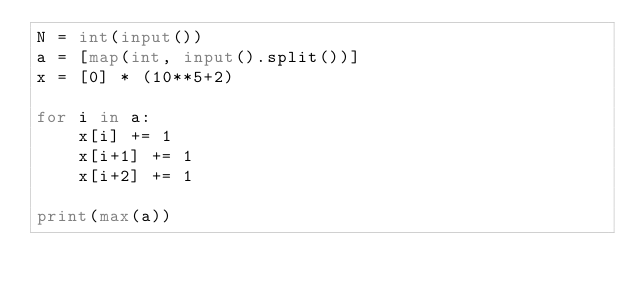Convert code to text. <code><loc_0><loc_0><loc_500><loc_500><_Python_>N = int(input())
a = [map(int, input().split())]
x = [0] * (10**5+2)

for i in a:
    x[i] += 1
    x[i+1] += 1
    x[i+2] += 1 
    
print(max(a))
    </code> 